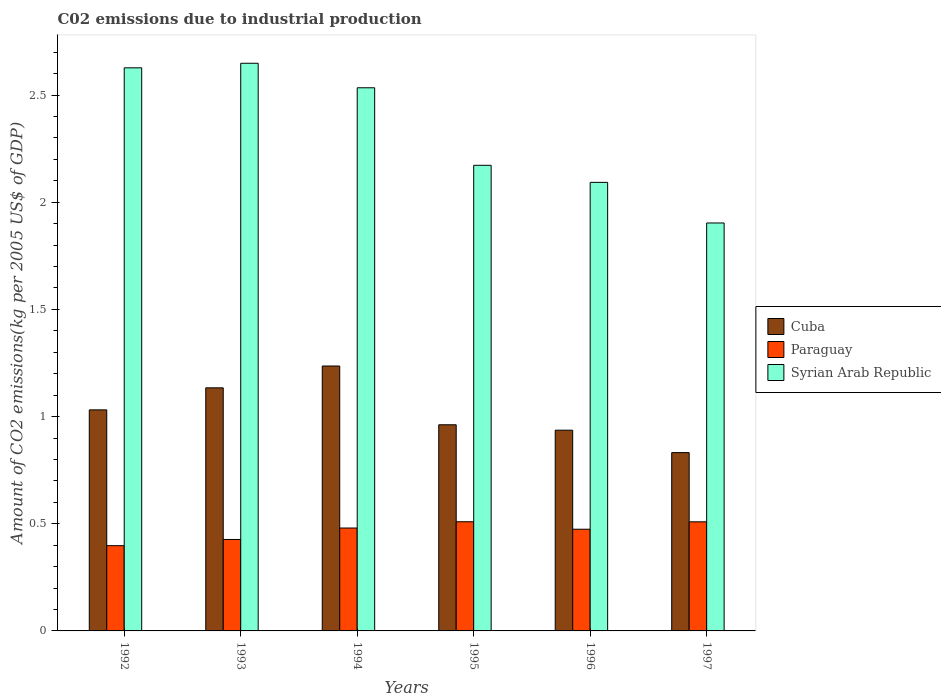How many groups of bars are there?
Offer a terse response. 6. Are the number of bars per tick equal to the number of legend labels?
Your response must be concise. Yes. How many bars are there on the 2nd tick from the left?
Offer a terse response. 3. How many bars are there on the 5th tick from the right?
Give a very brief answer. 3. What is the label of the 5th group of bars from the left?
Provide a short and direct response. 1996. What is the amount of CO2 emitted due to industrial production in Syrian Arab Republic in 1997?
Give a very brief answer. 1.9. Across all years, what is the maximum amount of CO2 emitted due to industrial production in Paraguay?
Make the answer very short. 0.51. Across all years, what is the minimum amount of CO2 emitted due to industrial production in Syrian Arab Republic?
Your answer should be very brief. 1.9. In which year was the amount of CO2 emitted due to industrial production in Syrian Arab Republic minimum?
Ensure brevity in your answer.  1997. What is the total amount of CO2 emitted due to industrial production in Syrian Arab Republic in the graph?
Ensure brevity in your answer.  13.98. What is the difference between the amount of CO2 emitted due to industrial production in Cuba in 1992 and that in 1995?
Keep it short and to the point. 0.07. What is the difference between the amount of CO2 emitted due to industrial production in Syrian Arab Republic in 1992 and the amount of CO2 emitted due to industrial production in Paraguay in 1993?
Your response must be concise. 2.2. What is the average amount of CO2 emitted due to industrial production in Paraguay per year?
Give a very brief answer. 0.47. In the year 1995, what is the difference between the amount of CO2 emitted due to industrial production in Paraguay and amount of CO2 emitted due to industrial production in Cuba?
Your answer should be very brief. -0.45. What is the ratio of the amount of CO2 emitted due to industrial production in Cuba in 1995 to that in 1997?
Ensure brevity in your answer.  1.16. Is the amount of CO2 emitted due to industrial production in Syrian Arab Republic in 1993 less than that in 1994?
Your answer should be very brief. No. Is the difference between the amount of CO2 emitted due to industrial production in Paraguay in 1993 and 1995 greater than the difference between the amount of CO2 emitted due to industrial production in Cuba in 1993 and 1995?
Give a very brief answer. No. What is the difference between the highest and the second highest amount of CO2 emitted due to industrial production in Paraguay?
Keep it short and to the point. 0. What is the difference between the highest and the lowest amount of CO2 emitted due to industrial production in Paraguay?
Ensure brevity in your answer.  0.11. In how many years, is the amount of CO2 emitted due to industrial production in Paraguay greater than the average amount of CO2 emitted due to industrial production in Paraguay taken over all years?
Give a very brief answer. 4. Is the sum of the amount of CO2 emitted due to industrial production in Syrian Arab Republic in 1992 and 1996 greater than the maximum amount of CO2 emitted due to industrial production in Paraguay across all years?
Offer a terse response. Yes. What does the 1st bar from the left in 1993 represents?
Your response must be concise. Cuba. What does the 1st bar from the right in 1997 represents?
Give a very brief answer. Syrian Arab Republic. Is it the case that in every year, the sum of the amount of CO2 emitted due to industrial production in Syrian Arab Republic and amount of CO2 emitted due to industrial production in Cuba is greater than the amount of CO2 emitted due to industrial production in Paraguay?
Your answer should be very brief. Yes. How many bars are there?
Provide a succinct answer. 18. Are all the bars in the graph horizontal?
Give a very brief answer. No. Does the graph contain grids?
Give a very brief answer. No. How many legend labels are there?
Offer a terse response. 3. What is the title of the graph?
Offer a very short reply. C02 emissions due to industrial production. Does "Iran" appear as one of the legend labels in the graph?
Keep it short and to the point. No. What is the label or title of the Y-axis?
Make the answer very short. Amount of CO2 emissions(kg per 2005 US$ of GDP). What is the Amount of CO2 emissions(kg per 2005 US$ of GDP) of Cuba in 1992?
Keep it short and to the point. 1.03. What is the Amount of CO2 emissions(kg per 2005 US$ of GDP) of Paraguay in 1992?
Your answer should be very brief. 0.4. What is the Amount of CO2 emissions(kg per 2005 US$ of GDP) of Syrian Arab Republic in 1992?
Make the answer very short. 2.63. What is the Amount of CO2 emissions(kg per 2005 US$ of GDP) of Cuba in 1993?
Offer a terse response. 1.13. What is the Amount of CO2 emissions(kg per 2005 US$ of GDP) in Paraguay in 1993?
Provide a succinct answer. 0.43. What is the Amount of CO2 emissions(kg per 2005 US$ of GDP) of Syrian Arab Republic in 1993?
Your response must be concise. 2.65. What is the Amount of CO2 emissions(kg per 2005 US$ of GDP) of Cuba in 1994?
Give a very brief answer. 1.24. What is the Amount of CO2 emissions(kg per 2005 US$ of GDP) in Paraguay in 1994?
Ensure brevity in your answer.  0.48. What is the Amount of CO2 emissions(kg per 2005 US$ of GDP) of Syrian Arab Republic in 1994?
Offer a very short reply. 2.53. What is the Amount of CO2 emissions(kg per 2005 US$ of GDP) of Cuba in 1995?
Offer a very short reply. 0.96. What is the Amount of CO2 emissions(kg per 2005 US$ of GDP) in Paraguay in 1995?
Your response must be concise. 0.51. What is the Amount of CO2 emissions(kg per 2005 US$ of GDP) of Syrian Arab Republic in 1995?
Your answer should be very brief. 2.17. What is the Amount of CO2 emissions(kg per 2005 US$ of GDP) in Cuba in 1996?
Your answer should be compact. 0.94. What is the Amount of CO2 emissions(kg per 2005 US$ of GDP) of Paraguay in 1996?
Ensure brevity in your answer.  0.47. What is the Amount of CO2 emissions(kg per 2005 US$ of GDP) in Syrian Arab Republic in 1996?
Your answer should be compact. 2.09. What is the Amount of CO2 emissions(kg per 2005 US$ of GDP) of Cuba in 1997?
Make the answer very short. 0.83. What is the Amount of CO2 emissions(kg per 2005 US$ of GDP) of Paraguay in 1997?
Keep it short and to the point. 0.51. What is the Amount of CO2 emissions(kg per 2005 US$ of GDP) of Syrian Arab Republic in 1997?
Your answer should be compact. 1.9. Across all years, what is the maximum Amount of CO2 emissions(kg per 2005 US$ of GDP) in Cuba?
Give a very brief answer. 1.24. Across all years, what is the maximum Amount of CO2 emissions(kg per 2005 US$ of GDP) of Paraguay?
Keep it short and to the point. 0.51. Across all years, what is the maximum Amount of CO2 emissions(kg per 2005 US$ of GDP) in Syrian Arab Republic?
Offer a terse response. 2.65. Across all years, what is the minimum Amount of CO2 emissions(kg per 2005 US$ of GDP) in Cuba?
Keep it short and to the point. 0.83. Across all years, what is the minimum Amount of CO2 emissions(kg per 2005 US$ of GDP) in Paraguay?
Your answer should be compact. 0.4. Across all years, what is the minimum Amount of CO2 emissions(kg per 2005 US$ of GDP) in Syrian Arab Republic?
Keep it short and to the point. 1.9. What is the total Amount of CO2 emissions(kg per 2005 US$ of GDP) of Cuba in the graph?
Your response must be concise. 6.13. What is the total Amount of CO2 emissions(kg per 2005 US$ of GDP) of Paraguay in the graph?
Offer a terse response. 2.8. What is the total Amount of CO2 emissions(kg per 2005 US$ of GDP) in Syrian Arab Republic in the graph?
Provide a short and direct response. 13.98. What is the difference between the Amount of CO2 emissions(kg per 2005 US$ of GDP) of Cuba in 1992 and that in 1993?
Ensure brevity in your answer.  -0.1. What is the difference between the Amount of CO2 emissions(kg per 2005 US$ of GDP) of Paraguay in 1992 and that in 1993?
Keep it short and to the point. -0.03. What is the difference between the Amount of CO2 emissions(kg per 2005 US$ of GDP) in Syrian Arab Republic in 1992 and that in 1993?
Your response must be concise. -0.02. What is the difference between the Amount of CO2 emissions(kg per 2005 US$ of GDP) of Cuba in 1992 and that in 1994?
Ensure brevity in your answer.  -0.2. What is the difference between the Amount of CO2 emissions(kg per 2005 US$ of GDP) in Paraguay in 1992 and that in 1994?
Make the answer very short. -0.08. What is the difference between the Amount of CO2 emissions(kg per 2005 US$ of GDP) of Syrian Arab Republic in 1992 and that in 1994?
Your response must be concise. 0.09. What is the difference between the Amount of CO2 emissions(kg per 2005 US$ of GDP) in Cuba in 1992 and that in 1995?
Provide a succinct answer. 0.07. What is the difference between the Amount of CO2 emissions(kg per 2005 US$ of GDP) of Paraguay in 1992 and that in 1995?
Keep it short and to the point. -0.11. What is the difference between the Amount of CO2 emissions(kg per 2005 US$ of GDP) in Syrian Arab Republic in 1992 and that in 1995?
Provide a succinct answer. 0.45. What is the difference between the Amount of CO2 emissions(kg per 2005 US$ of GDP) in Cuba in 1992 and that in 1996?
Ensure brevity in your answer.  0.09. What is the difference between the Amount of CO2 emissions(kg per 2005 US$ of GDP) in Paraguay in 1992 and that in 1996?
Provide a short and direct response. -0.08. What is the difference between the Amount of CO2 emissions(kg per 2005 US$ of GDP) in Syrian Arab Republic in 1992 and that in 1996?
Provide a short and direct response. 0.53. What is the difference between the Amount of CO2 emissions(kg per 2005 US$ of GDP) of Cuba in 1992 and that in 1997?
Ensure brevity in your answer.  0.2. What is the difference between the Amount of CO2 emissions(kg per 2005 US$ of GDP) in Paraguay in 1992 and that in 1997?
Offer a very short reply. -0.11. What is the difference between the Amount of CO2 emissions(kg per 2005 US$ of GDP) in Syrian Arab Republic in 1992 and that in 1997?
Provide a short and direct response. 0.72. What is the difference between the Amount of CO2 emissions(kg per 2005 US$ of GDP) of Cuba in 1993 and that in 1994?
Your answer should be very brief. -0.1. What is the difference between the Amount of CO2 emissions(kg per 2005 US$ of GDP) in Paraguay in 1993 and that in 1994?
Your response must be concise. -0.05. What is the difference between the Amount of CO2 emissions(kg per 2005 US$ of GDP) of Syrian Arab Republic in 1993 and that in 1994?
Ensure brevity in your answer.  0.11. What is the difference between the Amount of CO2 emissions(kg per 2005 US$ of GDP) in Cuba in 1993 and that in 1995?
Provide a succinct answer. 0.17. What is the difference between the Amount of CO2 emissions(kg per 2005 US$ of GDP) in Paraguay in 1993 and that in 1995?
Give a very brief answer. -0.08. What is the difference between the Amount of CO2 emissions(kg per 2005 US$ of GDP) of Syrian Arab Republic in 1993 and that in 1995?
Offer a very short reply. 0.48. What is the difference between the Amount of CO2 emissions(kg per 2005 US$ of GDP) in Cuba in 1993 and that in 1996?
Your answer should be very brief. 0.2. What is the difference between the Amount of CO2 emissions(kg per 2005 US$ of GDP) in Paraguay in 1993 and that in 1996?
Give a very brief answer. -0.05. What is the difference between the Amount of CO2 emissions(kg per 2005 US$ of GDP) of Syrian Arab Republic in 1993 and that in 1996?
Provide a succinct answer. 0.56. What is the difference between the Amount of CO2 emissions(kg per 2005 US$ of GDP) in Cuba in 1993 and that in 1997?
Offer a very short reply. 0.3. What is the difference between the Amount of CO2 emissions(kg per 2005 US$ of GDP) in Paraguay in 1993 and that in 1997?
Provide a short and direct response. -0.08. What is the difference between the Amount of CO2 emissions(kg per 2005 US$ of GDP) in Syrian Arab Republic in 1993 and that in 1997?
Offer a terse response. 0.75. What is the difference between the Amount of CO2 emissions(kg per 2005 US$ of GDP) of Cuba in 1994 and that in 1995?
Offer a very short reply. 0.27. What is the difference between the Amount of CO2 emissions(kg per 2005 US$ of GDP) in Paraguay in 1994 and that in 1995?
Give a very brief answer. -0.03. What is the difference between the Amount of CO2 emissions(kg per 2005 US$ of GDP) of Syrian Arab Republic in 1994 and that in 1995?
Give a very brief answer. 0.36. What is the difference between the Amount of CO2 emissions(kg per 2005 US$ of GDP) in Cuba in 1994 and that in 1996?
Your answer should be compact. 0.3. What is the difference between the Amount of CO2 emissions(kg per 2005 US$ of GDP) in Paraguay in 1994 and that in 1996?
Your answer should be compact. 0.01. What is the difference between the Amount of CO2 emissions(kg per 2005 US$ of GDP) of Syrian Arab Republic in 1994 and that in 1996?
Offer a very short reply. 0.44. What is the difference between the Amount of CO2 emissions(kg per 2005 US$ of GDP) in Cuba in 1994 and that in 1997?
Offer a very short reply. 0.4. What is the difference between the Amount of CO2 emissions(kg per 2005 US$ of GDP) of Paraguay in 1994 and that in 1997?
Give a very brief answer. -0.03. What is the difference between the Amount of CO2 emissions(kg per 2005 US$ of GDP) of Syrian Arab Republic in 1994 and that in 1997?
Your response must be concise. 0.63. What is the difference between the Amount of CO2 emissions(kg per 2005 US$ of GDP) of Cuba in 1995 and that in 1996?
Provide a short and direct response. 0.03. What is the difference between the Amount of CO2 emissions(kg per 2005 US$ of GDP) in Paraguay in 1995 and that in 1996?
Your response must be concise. 0.03. What is the difference between the Amount of CO2 emissions(kg per 2005 US$ of GDP) in Syrian Arab Republic in 1995 and that in 1996?
Ensure brevity in your answer.  0.08. What is the difference between the Amount of CO2 emissions(kg per 2005 US$ of GDP) in Cuba in 1995 and that in 1997?
Your answer should be very brief. 0.13. What is the difference between the Amount of CO2 emissions(kg per 2005 US$ of GDP) in Paraguay in 1995 and that in 1997?
Offer a terse response. 0. What is the difference between the Amount of CO2 emissions(kg per 2005 US$ of GDP) in Syrian Arab Republic in 1995 and that in 1997?
Your response must be concise. 0.27. What is the difference between the Amount of CO2 emissions(kg per 2005 US$ of GDP) of Cuba in 1996 and that in 1997?
Provide a short and direct response. 0.1. What is the difference between the Amount of CO2 emissions(kg per 2005 US$ of GDP) of Paraguay in 1996 and that in 1997?
Make the answer very short. -0.03. What is the difference between the Amount of CO2 emissions(kg per 2005 US$ of GDP) of Syrian Arab Republic in 1996 and that in 1997?
Provide a succinct answer. 0.19. What is the difference between the Amount of CO2 emissions(kg per 2005 US$ of GDP) in Cuba in 1992 and the Amount of CO2 emissions(kg per 2005 US$ of GDP) in Paraguay in 1993?
Your answer should be very brief. 0.6. What is the difference between the Amount of CO2 emissions(kg per 2005 US$ of GDP) in Cuba in 1992 and the Amount of CO2 emissions(kg per 2005 US$ of GDP) in Syrian Arab Republic in 1993?
Give a very brief answer. -1.62. What is the difference between the Amount of CO2 emissions(kg per 2005 US$ of GDP) of Paraguay in 1992 and the Amount of CO2 emissions(kg per 2005 US$ of GDP) of Syrian Arab Republic in 1993?
Your response must be concise. -2.25. What is the difference between the Amount of CO2 emissions(kg per 2005 US$ of GDP) of Cuba in 1992 and the Amount of CO2 emissions(kg per 2005 US$ of GDP) of Paraguay in 1994?
Your answer should be very brief. 0.55. What is the difference between the Amount of CO2 emissions(kg per 2005 US$ of GDP) in Cuba in 1992 and the Amount of CO2 emissions(kg per 2005 US$ of GDP) in Syrian Arab Republic in 1994?
Your answer should be very brief. -1.5. What is the difference between the Amount of CO2 emissions(kg per 2005 US$ of GDP) in Paraguay in 1992 and the Amount of CO2 emissions(kg per 2005 US$ of GDP) in Syrian Arab Republic in 1994?
Your response must be concise. -2.14. What is the difference between the Amount of CO2 emissions(kg per 2005 US$ of GDP) in Cuba in 1992 and the Amount of CO2 emissions(kg per 2005 US$ of GDP) in Paraguay in 1995?
Ensure brevity in your answer.  0.52. What is the difference between the Amount of CO2 emissions(kg per 2005 US$ of GDP) in Cuba in 1992 and the Amount of CO2 emissions(kg per 2005 US$ of GDP) in Syrian Arab Republic in 1995?
Your answer should be very brief. -1.14. What is the difference between the Amount of CO2 emissions(kg per 2005 US$ of GDP) in Paraguay in 1992 and the Amount of CO2 emissions(kg per 2005 US$ of GDP) in Syrian Arab Republic in 1995?
Your answer should be very brief. -1.77. What is the difference between the Amount of CO2 emissions(kg per 2005 US$ of GDP) of Cuba in 1992 and the Amount of CO2 emissions(kg per 2005 US$ of GDP) of Paraguay in 1996?
Provide a short and direct response. 0.56. What is the difference between the Amount of CO2 emissions(kg per 2005 US$ of GDP) in Cuba in 1992 and the Amount of CO2 emissions(kg per 2005 US$ of GDP) in Syrian Arab Republic in 1996?
Provide a succinct answer. -1.06. What is the difference between the Amount of CO2 emissions(kg per 2005 US$ of GDP) in Paraguay in 1992 and the Amount of CO2 emissions(kg per 2005 US$ of GDP) in Syrian Arab Republic in 1996?
Your response must be concise. -1.7. What is the difference between the Amount of CO2 emissions(kg per 2005 US$ of GDP) in Cuba in 1992 and the Amount of CO2 emissions(kg per 2005 US$ of GDP) in Paraguay in 1997?
Provide a short and direct response. 0.52. What is the difference between the Amount of CO2 emissions(kg per 2005 US$ of GDP) in Cuba in 1992 and the Amount of CO2 emissions(kg per 2005 US$ of GDP) in Syrian Arab Republic in 1997?
Provide a short and direct response. -0.87. What is the difference between the Amount of CO2 emissions(kg per 2005 US$ of GDP) in Paraguay in 1992 and the Amount of CO2 emissions(kg per 2005 US$ of GDP) in Syrian Arab Republic in 1997?
Your answer should be very brief. -1.51. What is the difference between the Amount of CO2 emissions(kg per 2005 US$ of GDP) in Cuba in 1993 and the Amount of CO2 emissions(kg per 2005 US$ of GDP) in Paraguay in 1994?
Provide a succinct answer. 0.65. What is the difference between the Amount of CO2 emissions(kg per 2005 US$ of GDP) of Cuba in 1993 and the Amount of CO2 emissions(kg per 2005 US$ of GDP) of Syrian Arab Republic in 1994?
Offer a terse response. -1.4. What is the difference between the Amount of CO2 emissions(kg per 2005 US$ of GDP) of Paraguay in 1993 and the Amount of CO2 emissions(kg per 2005 US$ of GDP) of Syrian Arab Republic in 1994?
Give a very brief answer. -2.11. What is the difference between the Amount of CO2 emissions(kg per 2005 US$ of GDP) in Cuba in 1993 and the Amount of CO2 emissions(kg per 2005 US$ of GDP) in Paraguay in 1995?
Make the answer very short. 0.62. What is the difference between the Amount of CO2 emissions(kg per 2005 US$ of GDP) of Cuba in 1993 and the Amount of CO2 emissions(kg per 2005 US$ of GDP) of Syrian Arab Republic in 1995?
Your answer should be compact. -1.04. What is the difference between the Amount of CO2 emissions(kg per 2005 US$ of GDP) of Paraguay in 1993 and the Amount of CO2 emissions(kg per 2005 US$ of GDP) of Syrian Arab Republic in 1995?
Your answer should be very brief. -1.75. What is the difference between the Amount of CO2 emissions(kg per 2005 US$ of GDP) in Cuba in 1993 and the Amount of CO2 emissions(kg per 2005 US$ of GDP) in Paraguay in 1996?
Make the answer very short. 0.66. What is the difference between the Amount of CO2 emissions(kg per 2005 US$ of GDP) in Cuba in 1993 and the Amount of CO2 emissions(kg per 2005 US$ of GDP) in Syrian Arab Republic in 1996?
Keep it short and to the point. -0.96. What is the difference between the Amount of CO2 emissions(kg per 2005 US$ of GDP) in Paraguay in 1993 and the Amount of CO2 emissions(kg per 2005 US$ of GDP) in Syrian Arab Republic in 1996?
Offer a very short reply. -1.67. What is the difference between the Amount of CO2 emissions(kg per 2005 US$ of GDP) of Cuba in 1993 and the Amount of CO2 emissions(kg per 2005 US$ of GDP) of Paraguay in 1997?
Provide a succinct answer. 0.63. What is the difference between the Amount of CO2 emissions(kg per 2005 US$ of GDP) of Cuba in 1993 and the Amount of CO2 emissions(kg per 2005 US$ of GDP) of Syrian Arab Republic in 1997?
Your answer should be compact. -0.77. What is the difference between the Amount of CO2 emissions(kg per 2005 US$ of GDP) of Paraguay in 1993 and the Amount of CO2 emissions(kg per 2005 US$ of GDP) of Syrian Arab Republic in 1997?
Offer a very short reply. -1.48. What is the difference between the Amount of CO2 emissions(kg per 2005 US$ of GDP) in Cuba in 1994 and the Amount of CO2 emissions(kg per 2005 US$ of GDP) in Paraguay in 1995?
Give a very brief answer. 0.73. What is the difference between the Amount of CO2 emissions(kg per 2005 US$ of GDP) in Cuba in 1994 and the Amount of CO2 emissions(kg per 2005 US$ of GDP) in Syrian Arab Republic in 1995?
Keep it short and to the point. -0.94. What is the difference between the Amount of CO2 emissions(kg per 2005 US$ of GDP) of Paraguay in 1994 and the Amount of CO2 emissions(kg per 2005 US$ of GDP) of Syrian Arab Republic in 1995?
Offer a terse response. -1.69. What is the difference between the Amount of CO2 emissions(kg per 2005 US$ of GDP) in Cuba in 1994 and the Amount of CO2 emissions(kg per 2005 US$ of GDP) in Paraguay in 1996?
Provide a short and direct response. 0.76. What is the difference between the Amount of CO2 emissions(kg per 2005 US$ of GDP) in Cuba in 1994 and the Amount of CO2 emissions(kg per 2005 US$ of GDP) in Syrian Arab Republic in 1996?
Make the answer very short. -0.86. What is the difference between the Amount of CO2 emissions(kg per 2005 US$ of GDP) of Paraguay in 1994 and the Amount of CO2 emissions(kg per 2005 US$ of GDP) of Syrian Arab Republic in 1996?
Offer a very short reply. -1.61. What is the difference between the Amount of CO2 emissions(kg per 2005 US$ of GDP) of Cuba in 1994 and the Amount of CO2 emissions(kg per 2005 US$ of GDP) of Paraguay in 1997?
Give a very brief answer. 0.73. What is the difference between the Amount of CO2 emissions(kg per 2005 US$ of GDP) of Cuba in 1994 and the Amount of CO2 emissions(kg per 2005 US$ of GDP) of Syrian Arab Republic in 1997?
Ensure brevity in your answer.  -0.67. What is the difference between the Amount of CO2 emissions(kg per 2005 US$ of GDP) in Paraguay in 1994 and the Amount of CO2 emissions(kg per 2005 US$ of GDP) in Syrian Arab Republic in 1997?
Ensure brevity in your answer.  -1.42. What is the difference between the Amount of CO2 emissions(kg per 2005 US$ of GDP) of Cuba in 1995 and the Amount of CO2 emissions(kg per 2005 US$ of GDP) of Paraguay in 1996?
Ensure brevity in your answer.  0.49. What is the difference between the Amount of CO2 emissions(kg per 2005 US$ of GDP) in Cuba in 1995 and the Amount of CO2 emissions(kg per 2005 US$ of GDP) in Syrian Arab Republic in 1996?
Provide a short and direct response. -1.13. What is the difference between the Amount of CO2 emissions(kg per 2005 US$ of GDP) of Paraguay in 1995 and the Amount of CO2 emissions(kg per 2005 US$ of GDP) of Syrian Arab Republic in 1996?
Your response must be concise. -1.58. What is the difference between the Amount of CO2 emissions(kg per 2005 US$ of GDP) of Cuba in 1995 and the Amount of CO2 emissions(kg per 2005 US$ of GDP) of Paraguay in 1997?
Keep it short and to the point. 0.45. What is the difference between the Amount of CO2 emissions(kg per 2005 US$ of GDP) in Cuba in 1995 and the Amount of CO2 emissions(kg per 2005 US$ of GDP) in Syrian Arab Republic in 1997?
Provide a short and direct response. -0.94. What is the difference between the Amount of CO2 emissions(kg per 2005 US$ of GDP) of Paraguay in 1995 and the Amount of CO2 emissions(kg per 2005 US$ of GDP) of Syrian Arab Republic in 1997?
Your answer should be compact. -1.39. What is the difference between the Amount of CO2 emissions(kg per 2005 US$ of GDP) in Cuba in 1996 and the Amount of CO2 emissions(kg per 2005 US$ of GDP) in Paraguay in 1997?
Provide a short and direct response. 0.43. What is the difference between the Amount of CO2 emissions(kg per 2005 US$ of GDP) in Cuba in 1996 and the Amount of CO2 emissions(kg per 2005 US$ of GDP) in Syrian Arab Republic in 1997?
Offer a terse response. -0.97. What is the difference between the Amount of CO2 emissions(kg per 2005 US$ of GDP) in Paraguay in 1996 and the Amount of CO2 emissions(kg per 2005 US$ of GDP) in Syrian Arab Republic in 1997?
Give a very brief answer. -1.43. What is the average Amount of CO2 emissions(kg per 2005 US$ of GDP) in Cuba per year?
Give a very brief answer. 1.02. What is the average Amount of CO2 emissions(kg per 2005 US$ of GDP) in Paraguay per year?
Offer a very short reply. 0.47. What is the average Amount of CO2 emissions(kg per 2005 US$ of GDP) of Syrian Arab Republic per year?
Keep it short and to the point. 2.33. In the year 1992, what is the difference between the Amount of CO2 emissions(kg per 2005 US$ of GDP) in Cuba and Amount of CO2 emissions(kg per 2005 US$ of GDP) in Paraguay?
Ensure brevity in your answer.  0.63. In the year 1992, what is the difference between the Amount of CO2 emissions(kg per 2005 US$ of GDP) of Cuba and Amount of CO2 emissions(kg per 2005 US$ of GDP) of Syrian Arab Republic?
Give a very brief answer. -1.6. In the year 1992, what is the difference between the Amount of CO2 emissions(kg per 2005 US$ of GDP) in Paraguay and Amount of CO2 emissions(kg per 2005 US$ of GDP) in Syrian Arab Republic?
Your answer should be compact. -2.23. In the year 1993, what is the difference between the Amount of CO2 emissions(kg per 2005 US$ of GDP) of Cuba and Amount of CO2 emissions(kg per 2005 US$ of GDP) of Paraguay?
Make the answer very short. 0.71. In the year 1993, what is the difference between the Amount of CO2 emissions(kg per 2005 US$ of GDP) in Cuba and Amount of CO2 emissions(kg per 2005 US$ of GDP) in Syrian Arab Republic?
Provide a short and direct response. -1.51. In the year 1993, what is the difference between the Amount of CO2 emissions(kg per 2005 US$ of GDP) in Paraguay and Amount of CO2 emissions(kg per 2005 US$ of GDP) in Syrian Arab Republic?
Make the answer very short. -2.22. In the year 1994, what is the difference between the Amount of CO2 emissions(kg per 2005 US$ of GDP) of Cuba and Amount of CO2 emissions(kg per 2005 US$ of GDP) of Paraguay?
Provide a succinct answer. 0.76. In the year 1994, what is the difference between the Amount of CO2 emissions(kg per 2005 US$ of GDP) in Cuba and Amount of CO2 emissions(kg per 2005 US$ of GDP) in Syrian Arab Republic?
Give a very brief answer. -1.3. In the year 1994, what is the difference between the Amount of CO2 emissions(kg per 2005 US$ of GDP) in Paraguay and Amount of CO2 emissions(kg per 2005 US$ of GDP) in Syrian Arab Republic?
Your answer should be compact. -2.05. In the year 1995, what is the difference between the Amount of CO2 emissions(kg per 2005 US$ of GDP) of Cuba and Amount of CO2 emissions(kg per 2005 US$ of GDP) of Paraguay?
Your answer should be very brief. 0.45. In the year 1995, what is the difference between the Amount of CO2 emissions(kg per 2005 US$ of GDP) of Cuba and Amount of CO2 emissions(kg per 2005 US$ of GDP) of Syrian Arab Republic?
Your response must be concise. -1.21. In the year 1995, what is the difference between the Amount of CO2 emissions(kg per 2005 US$ of GDP) of Paraguay and Amount of CO2 emissions(kg per 2005 US$ of GDP) of Syrian Arab Republic?
Keep it short and to the point. -1.66. In the year 1996, what is the difference between the Amount of CO2 emissions(kg per 2005 US$ of GDP) of Cuba and Amount of CO2 emissions(kg per 2005 US$ of GDP) of Paraguay?
Your answer should be compact. 0.46. In the year 1996, what is the difference between the Amount of CO2 emissions(kg per 2005 US$ of GDP) of Cuba and Amount of CO2 emissions(kg per 2005 US$ of GDP) of Syrian Arab Republic?
Make the answer very short. -1.16. In the year 1996, what is the difference between the Amount of CO2 emissions(kg per 2005 US$ of GDP) in Paraguay and Amount of CO2 emissions(kg per 2005 US$ of GDP) in Syrian Arab Republic?
Make the answer very short. -1.62. In the year 1997, what is the difference between the Amount of CO2 emissions(kg per 2005 US$ of GDP) of Cuba and Amount of CO2 emissions(kg per 2005 US$ of GDP) of Paraguay?
Your answer should be compact. 0.32. In the year 1997, what is the difference between the Amount of CO2 emissions(kg per 2005 US$ of GDP) of Cuba and Amount of CO2 emissions(kg per 2005 US$ of GDP) of Syrian Arab Republic?
Give a very brief answer. -1.07. In the year 1997, what is the difference between the Amount of CO2 emissions(kg per 2005 US$ of GDP) in Paraguay and Amount of CO2 emissions(kg per 2005 US$ of GDP) in Syrian Arab Republic?
Give a very brief answer. -1.39. What is the ratio of the Amount of CO2 emissions(kg per 2005 US$ of GDP) of Cuba in 1992 to that in 1993?
Offer a very short reply. 0.91. What is the ratio of the Amount of CO2 emissions(kg per 2005 US$ of GDP) in Paraguay in 1992 to that in 1993?
Your answer should be very brief. 0.93. What is the ratio of the Amount of CO2 emissions(kg per 2005 US$ of GDP) of Syrian Arab Republic in 1992 to that in 1993?
Make the answer very short. 0.99. What is the ratio of the Amount of CO2 emissions(kg per 2005 US$ of GDP) of Cuba in 1992 to that in 1994?
Your answer should be compact. 0.83. What is the ratio of the Amount of CO2 emissions(kg per 2005 US$ of GDP) of Paraguay in 1992 to that in 1994?
Provide a short and direct response. 0.83. What is the ratio of the Amount of CO2 emissions(kg per 2005 US$ of GDP) of Syrian Arab Republic in 1992 to that in 1994?
Give a very brief answer. 1.04. What is the ratio of the Amount of CO2 emissions(kg per 2005 US$ of GDP) in Cuba in 1992 to that in 1995?
Offer a terse response. 1.07. What is the ratio of the Amount of CO2 emissions(kg per 2005 US$ of GDP) in Paraguay in 1992 to that in 1995?
Offer a terse response. 0.78. What is the ratio of the Amount of CO2 emissions(kg per 2005 US$ of GDP) in Syrian Arab Republic in 1992 to that in 1995?
Make the answer very short. 1.21. What is the ratio of the Amount of CO2 emissions(kg per 2005 US$ of GDP) in Cuba in 1992 to that in 1996?
Ensure brevity in your answer.  1.1. What is the ratio of the Amount of CO2 emissions(kg per 2005 US$ of GDP) in Paraguay in 1992 to that in 1996?
Your answer should be very brief. 0.84. What is the ratio of the Amount of CO2 emissions(kg per 2005 US$ of GDP) of Syrian Arab Republic in 1992 to that in 1996?
Offer a terse response. 1.26. What is the ratio of the Amount of CO2 emissions(kg per 2005 US$ of GDP) of Cuba in 1992 to that in 1997?
Keep it short and to the point. 1.24. What is the ratio of the Amount of CO2 emissions(kg per 2005 US$ of GDP) of Paraguay in 1992 to that in 1997?
Provide a succinct answer. 0.78. What is the ratio of the Amount of CO2 emissions(kg per 2005 US$ of GDP) in Syrian Arab Republic in 1992 to that in 1997?
Provide a short and direct response. 1.38. What is the ratio of the Amount of CO2 emissions(kg per 2005 US$ of GDP) of Cuba in 1993 to that in 1994?
Give a very brief answer. 0.92. What is the ratio of the Amount of CO2 emissions(kg per 2005 US$ of GDP) in Paraguay in 1993 to that in 1994?
Offer a terse response. 0.89. What is the ratio of the Amount of CO2 emissions(kg per 2005 US$ of GDP) of Syrian Arab Republic in 1993 to that in 1994?
Offer a very short reply. 1.05. What is the ratio of the Amount of CO2 emissions(kg per 2005 US$ of GDP) of Cuba in 1993 to that in 1995?
Offer a very short reply. 1.18. What is the ratio of the Amount of CO2 emissions(kg per 2005 US$ of GDP) in Paraguay in 1993 to that in 1995?
Provide a short and direct response. 0.84. What is the ratio of the Amount of CO2 emissions(kg per 2005 US$ of GDP) of Syrian Arab Republic in 1993 to that in 1995?
Your answer should be very brief. 1.22. What is the ratio of the Amount of CO2 emissions(kg per 2005 US$ of GDP) of Cuba in 1993 to that in 1996?
Give a very brief answer. 1.21. What is the ratio of the Amount of CO2 emissions(kg per 2005 US$ of GDP) in Paraguay in 1993 to that in 1996?
Your answer should be very brief. 0.9. What is the ratio of the Amount of CO2 emissions(kg per 2005 US$ of GDP) in Syrian Arab Republic in 1993 to that in 1996?
Ensure brevity in your answer.  1.27. What is the ratio of the Amount of CO2 emissions(kg per 2005 US$ of GDP) of Cuba in 1993 to that in 1997?
Give a very brief answer. 1.36. What is the ratio of the Amount of CO2 emissions(kg per 2005 US$ of GDP) in Paraguay in 1993 to that in 1997?
Provide a succinct answer. 0.84. What is the ratio of the Amount of CO2 emissions(kg per 2005 US$ of GDP) of Syrian Arab Republic in 1993 to that in 1997?
Your answer should be compact. 1.39. What is the ratio of the Amount of CO2 emissions(kg per 2005 US$ of GDP) of Cuba in 1994 to that in 1995?
Provide a succinct answer. 1.29. What is the ratio of the Amount of CO2 emissions(kg per 2005 US$ of GDP) of Paraguay in 1994 to that in 1995?
Keep it short and to the point. 0.94. What is the ratio of the Amount of CO2 emissions(kg per 2005 US$ of GDP) in Syrian Arab Republic in 1994 to that in 1995?
Provide a short and direct response. 1.17. What is the ratio of the Amount of CO2 emissions(kg per 2005 US$ of GDP) of Cuba in 1994 to that in 1996?
Your response must be concise. 1.32. What is the ratio of the Amount of CO2 emissions(kg per 2005 US$ of GDP) in Paraguay in 1994 to that in 1996?
Give a very brief answer. 1.01. What is the ratio of the Amount of CO2 emissions(kg per 2005 US$ of GDP) of Syrian Arab Republic in 1994 to that in 1996?
Give a very brief answer. 1.21. What is the ratio of the Amount of CO2 emissions(kg per 2005 US$ of GDP) of Cuba in 1994 to that in 1997?
Provide a short and direct response. 1.49. What is the ratio of the Amount of CO2 emissions(kg per 2005 US$ of GDP) of Paraguay in 1994 to that in 1997?
Offer a terse response. 0.94. What is the ratio of the Amount of CO2 emissions(kg per 2005 US$ of GDP) of Syrian Arab Republic in 1994 to that in 1997?
Offer a terse response. 1.33. What is the ratio of the Amount of CO2 emissions(kg per 2005 US$ of GDP) in Paraguay in 1995 to that in 1996?
Give a very brief answer. 1.07. What is the ratio of the Amount of CO2 emissions(kg per 2005 US$ of GDP) in Syrian Arab Republic in 1995 to that in 1996?
Give a very brief answer. 1.04. What is the ratio of the Amount of CO2 emissions(kg per 2005 US$ of GDP) in Cuba in 1995 to that in 1997?
Provide a succinct answer. 1.16. What is the ratio of the Amount of CO2 emissions(kg per 2005 US$ of GDP) of Syrian Arab Republic in 1995 to that in 1997?
Keep it short and to the point. 1.14. What is the ratio of the Amount of CO2 emissions(kg per 2005 US$ of GDP) in Cuba in 1996 to that in 1997?
Your answer should be very brief. 1.13. What is the ratio of the Amount of CO2 emissions(kg per 2005 US$ of GDP) of Paraguay in 1996 to that in 1997?
Keep it short and to the point. 0.93. What is the ratio of the Amount of CO2 emissions(kg per 2005 US$ of GDP) in Syrian Arab Republic in 1996 to that in 1997?
Your answer should be compact. 1.1. What is the difference between the highest and the second highest Amount of CO2 emissions(kg per 2005 US$ of GDP) in Cuba?
Ensure brevity in your answer.  0.1. What is the difference between the highest and the second highest Amount of CO2 emissions(kg per 2005 US$ of GDP) of Paraguay?
Keep it short and to the point. 0. What is the difference between the highest and the second highest Amount of CO2 emissions(kg per 2005 US$ of GDP) in Syrian Arab Republic?
Keep it short and to the point. 0.02. What is the difference between the highest and the lowest Amount of CO2 emissions(kg per 2005 US$ of GDP) of Cuba?
Ensure brevity in your answer.  0.4. What is the difference between the highest and the lowest Amount of CO2 emissions(kg per 2005 US$ of GDP) of Paraguay?
Your answer should be very brief. 0.11. What is the difference between the highest and the lowest Amount of CO2 emissions(kg per 2005 US$ of GDP) in Syrian Arab Republic?
Provide a succinct answer. 0.75. 